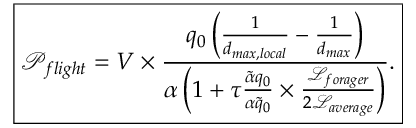Convert formula to latex. <formula><loc_0><loc_0><loc_500><loc_500>\boxed { \mathcal { P } _ { f l i g h t } = V \times \frac { q _ { 0 } \left ( \frac { 1 } { d _ { \max , l o c a l } } - \frac { 1 } { d _ { \max } } \right ) } { \alpha \left ( 1 + \tau \frac { \tilde { \alpha } q _ { 0 } } { \alpha \tilde { q } _ { 0 } } \times \frac { \mathcal { L } _ { f o r a g e r } } { 2 \mathcal { L } _ { a v e r a g e } } \right ) } . }</formula> 